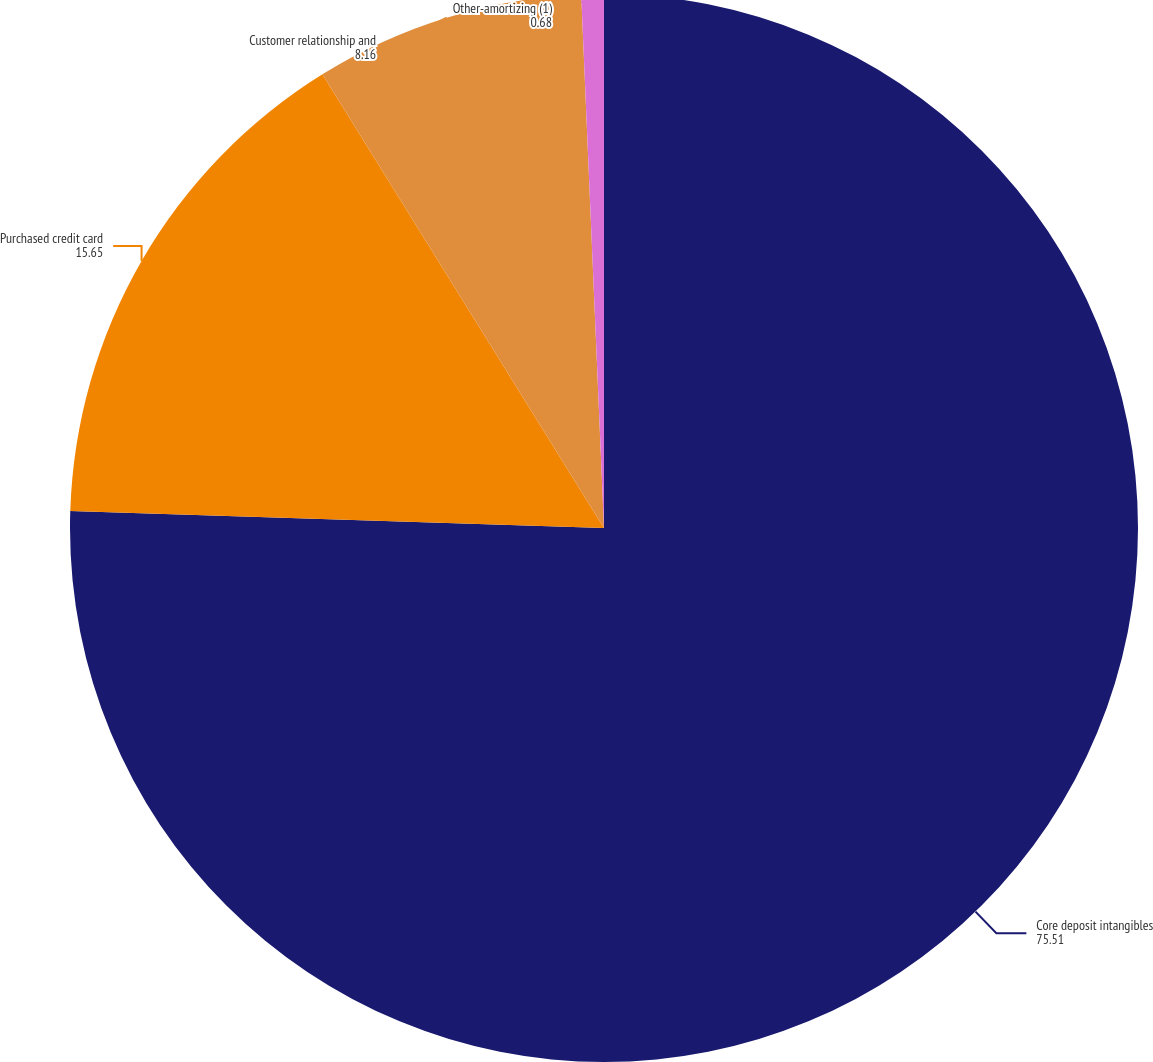Convert chart. <chart><loc_0><loc_0><loc_500><loc_500><pie_chart><fcel>Core deposit intangibles<fcel>Purchased credit card<fcel>Customer relationship and<fcel>Other-amortizing (1)<nl><fcel>75.51%<fcel>15.65%<fcel>8.16%<fcel>0.68%<nl></chart> 